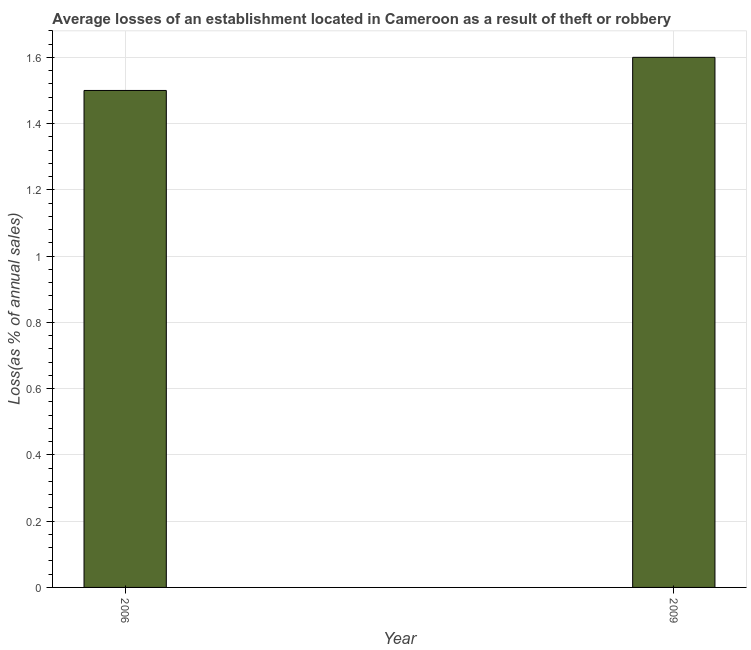What is the title of the graph?
Make the answer very short. Average losses of an establishment located in Cameroon as a result of theft or robbery. What is the label or title of the Y-axis?
Give a very brief answer. Loss(as % of annual sales). Across all years, what is the minimum losses due to theft?
Your answer should be compact. 1.5. In which year was the losses due to theft maximum?
Your answer should be very brief. 2009. What is the average losses due to theft per year?
Provide a succinct answer. 1.55. What is the median losses due to theft?
Keep it short and to the point. 1.55. In how many years, is the losses due to theft greater than 0.2 %?
Offer a terse response. 2. Do a majority of the years between 2009 and 2006 (inclusive) have losses due to theft greater than 0.4 %?
Offer a terse response. No. What is the ratio of the losses due to theft in 2006 to that in 2009?
Your answer should be compact. 0.94. Is the losses due to theft in 2006 less than that in 2009?
Ensure brevity in your answer.  Yes. In how many years, is the losses due to theft greater than the average losses due to theft taken over all years?
Your answer should be very brief. 1. How many bars are there?
Keep it short and to the point. 2. Are all the bars in the graph horizontal?
Provide a succinct answer. No. How many years are there in the graph?
Offer a terse response. 2. What is the difference between two consecutive major ticks on the Y-axis?
Keep it short and to the point. 0.2. Are the values on the major ticks of Y-axis written in scientific E-notation?
Offer a terse response. No. What is the Loss(as % of annual sales) in 2006?
Provide a succinct answer. 1.5. What is the Loss(as % of annual sales) in 2009?
Your answer should be compact. 1.6. What is the ratio of the Loss(as % of annual sales) in 2006 to that in 2009?
Give a very brief answer. 0.94. 